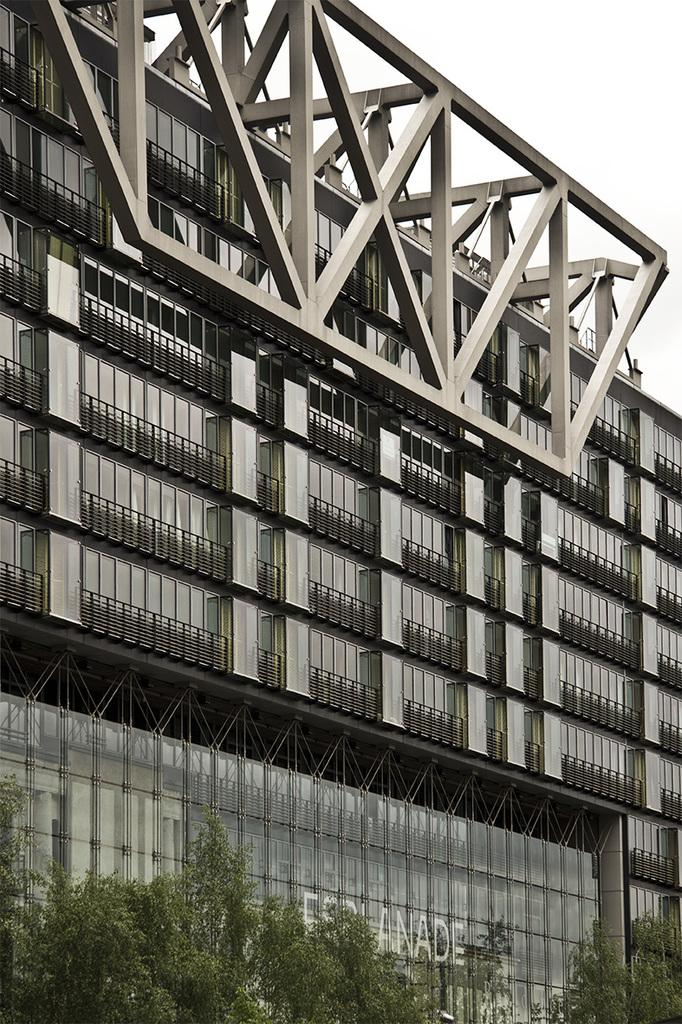What is the color and size of the building in the image? The building in the image is silver in color and big in size. What else can be seen in the image besides the building? There are many trees in the image. What is visible at the top of the image? The sky is visible at the top of the image. Can you tell me how many kittens are playing with a cast in the image? There are no kittens or casts present in the image; it features a silver color big glass building and many trees. What time of day is depicted in the image? The provided facts do not give information about the time of day, so it cannot be determined from the image. 